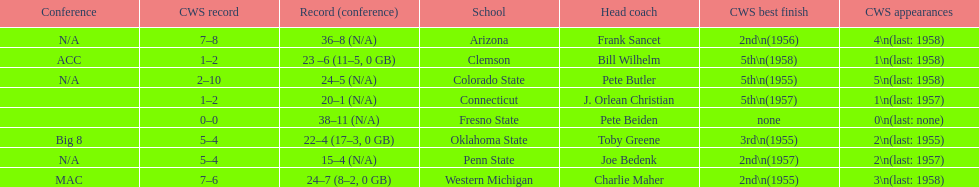What are the number of schools with more than 2 cws appearances? 3. 